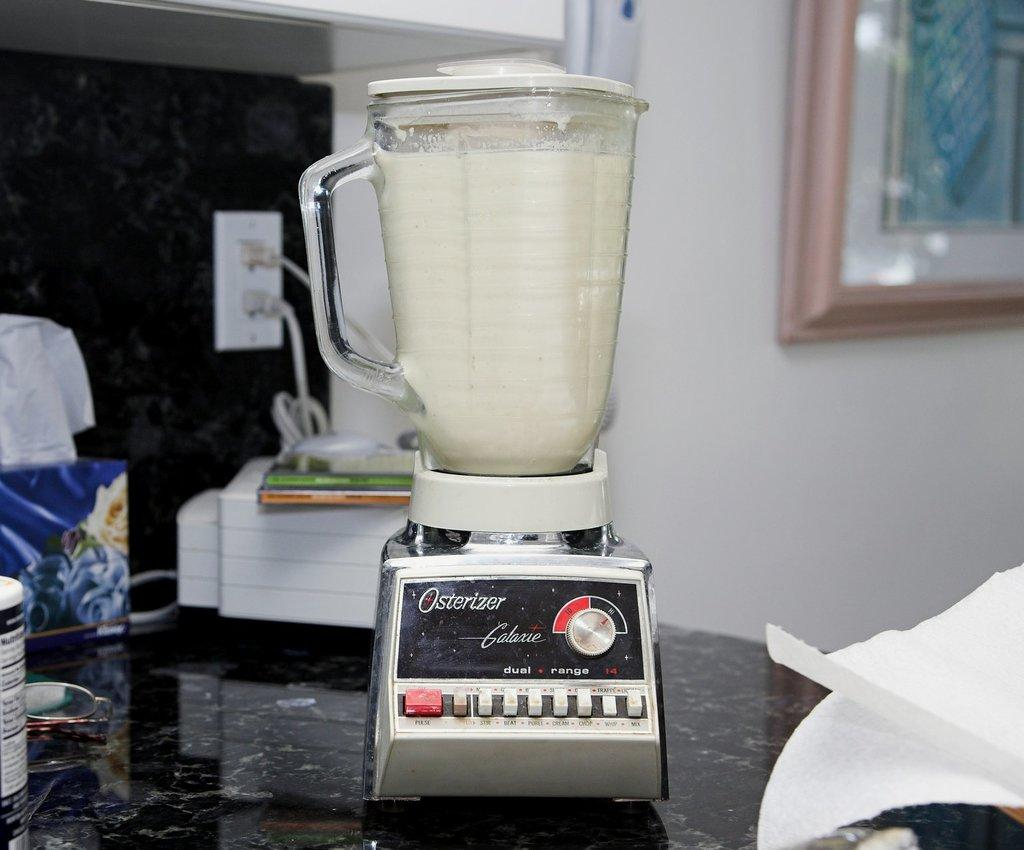<image>
Share a concise interpretation of the image provided. An Osterizer blender full of a white liquid on a counter. 